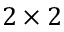Convert formula to latex. <formula><loc_0><loc_0><loc_500><loc_500>2 \times 2</formula> 